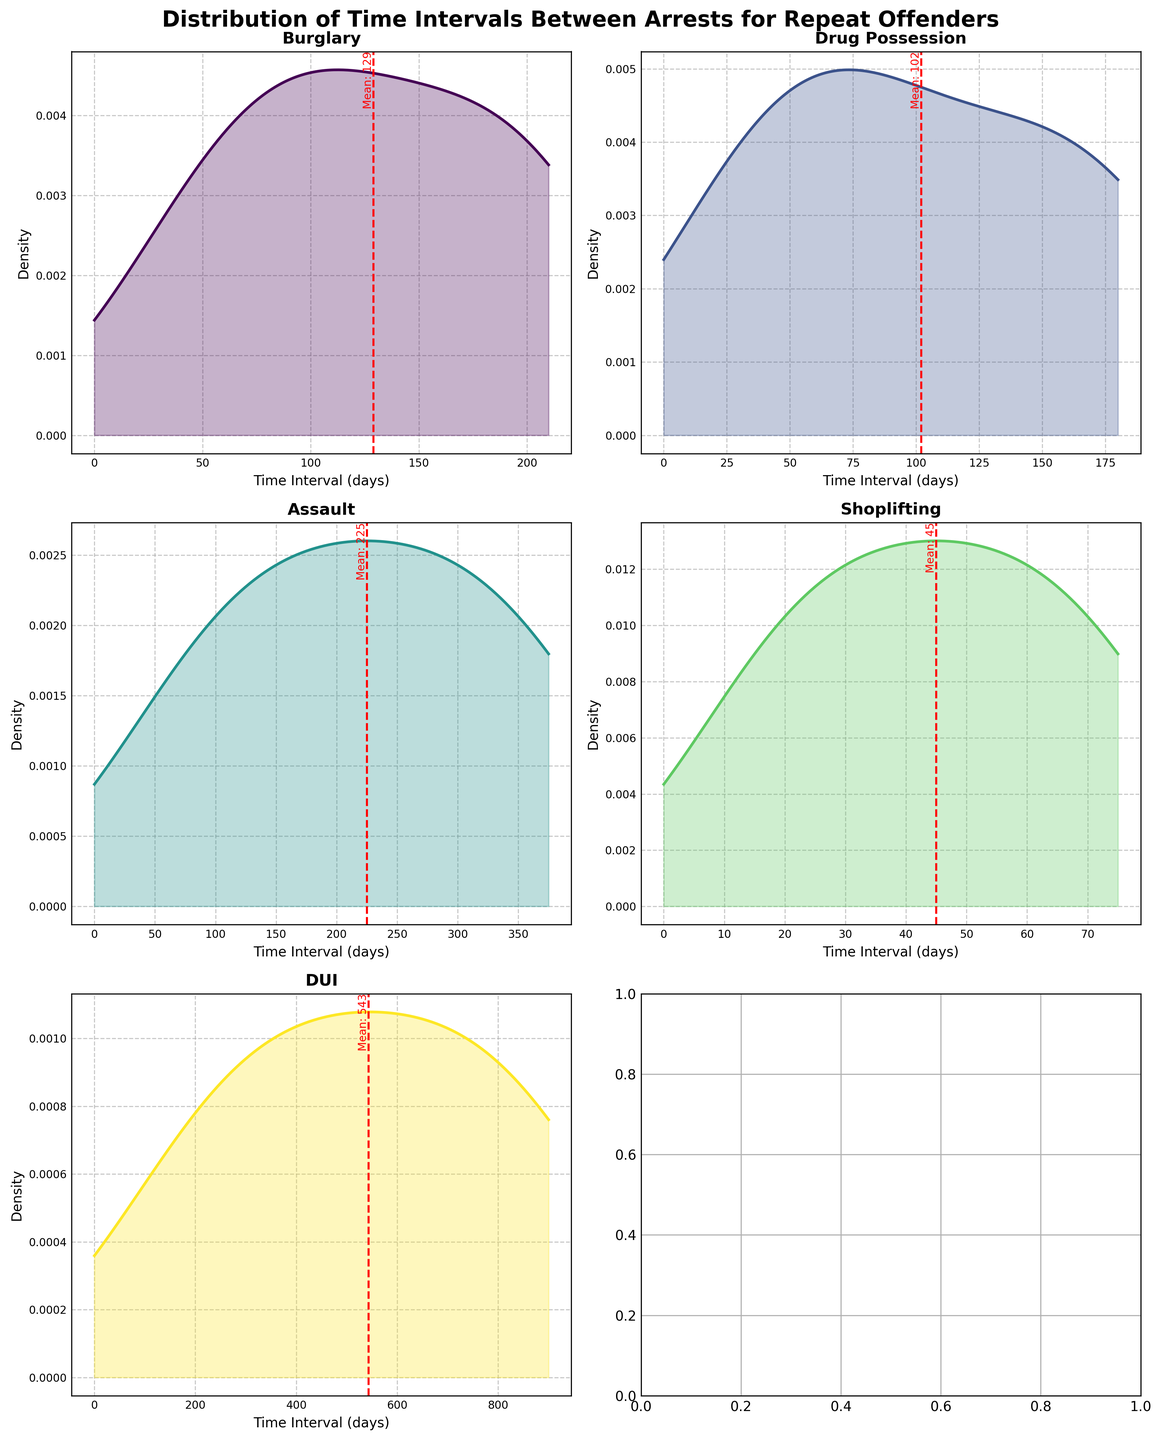What's the title of the figure? The title is usually found at the top of the figure and it summarizes what the figure is about.
Answer: Distribution of Time Intervals Between Arrests for Repeat Offenders What is the mean time interval between arrests for Burglary? The mean is the average value of the time intervals between arrests, marked with a red dashed line on the subplot for Burglary.
Answer: 129 Which offense type has the longest mean time interval between arrests? To determine this, look for the subplot with the red dashed line furthest to the right.
Answer: DUI Which offense type has the highest density peak? The highest density peak is found by looking at the tallest peak in each subplot's line.
Answer: Shoplifting How many offense types are presented in the figure? The number of offense types corresponds to the number of subplots shown.
Answer: 5 What is the range of time intervals for Drug Possession? The range is determined by checking the minimum and maximum values on the x-axis of the Drug Possession subplot.
Answer: 30 to 180 days How does the density distribution of Assault compare to DUI? Comparison involves looking at the shape and spread of the curves in the subplots for Assault and DUI.
Answer: Assault has a broader and lower density distribution compared to the narrow and higher distribution of DUI Which offense type has the shortest mean time interval between arrests? Identify this by finding the subplot with the red dashed line situated the furthest to the left.
Answer: Shoplifting What can you say about the variation of time intervals for DUI based on their density plot? Assessing variation involves looking at the spread of the distribution and the height of the peaks. DUI shows a wide spread indicating high variation.
Answer: High variation Do the time intervals for Burglary arrests show more uniformity compared to Drug Possession? Uniformity can be judged by looking at how narrow and peaked the density distribution is.
Answer: No, Burglary shows more spread while Drug Possession is more peaked 